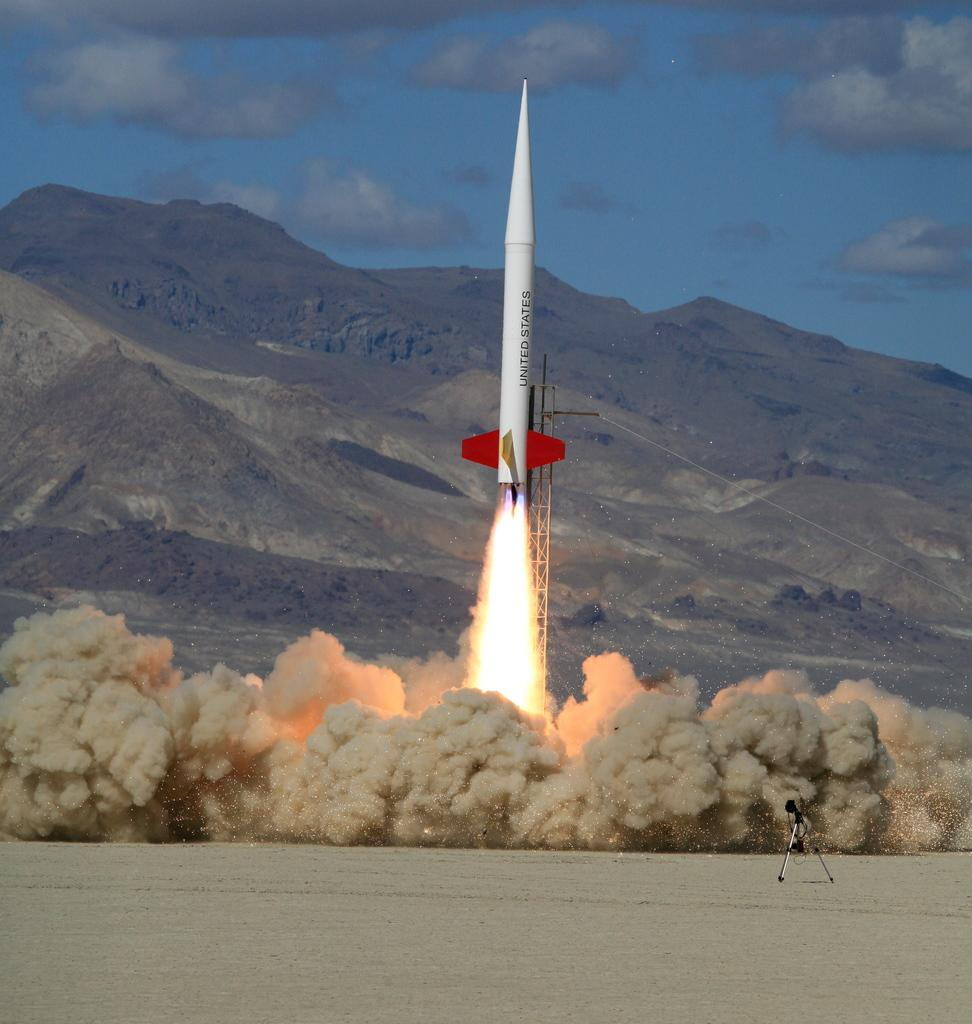Provide a one-sentence caption for the provided image. A United States rocket shoots off is a cloud of dust with fire trailing it. 